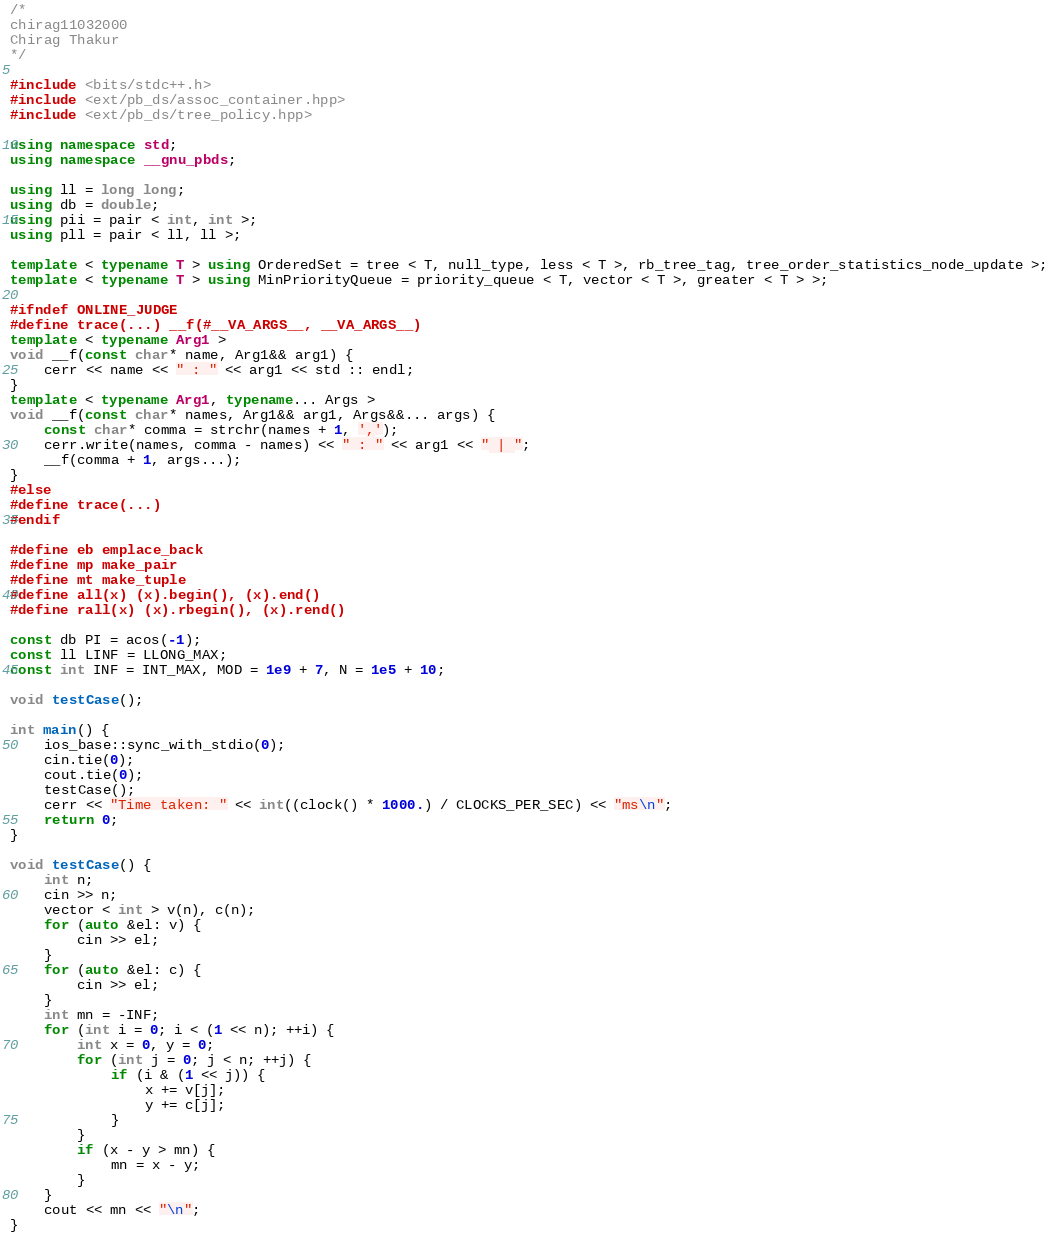Convert code to text. <code><loc_0><loc_0><loc_500><loc_500><_C++_>/* 
chirag11032000
Chirag Thakur
*/

#include <bits/stdc++.h>
#include <ext/pb_ds/assoc_container.hpp>
#include <ext/pb_ds/tree_policy.hpp>

using namespace std;
using namespace __gnu_pbds;

using ll = long long;
using db = double;
using pii = pair < int, int >;
using pll = pair < ll, ll >;

template < typename T > using OrderedSet = tree < T, null_type, less < T >, rb_tree_tag, tree_order_statistics_node_update >;
template < typename T > using MinPriorityQueue = priority_queue < T, vector < T >, greater < T > >;

#ifndef ONLINE_JUDGE
#define trace(...) __f(#__VA_ARGS__, __VA_ARGS__)
template < typename Arg1 >
void __f(const char* name, Arg1&& arg1) {
	cerr << name << " : " << arg1 << std :: endl;
}
template < typename Arg1, typename... Args >
void __f(const char* names, Arg1&& arg1, Args&&... args) {
	const char* comma = strchr(names + 1, ',');
	cerr.write(names, comma - names) << " : " << arg1 << " | ";
	__f(comma + 1, args...);
}
#else
#define trace(...)
#endif

#define eb emplace_back
#define mp make_pair
#define mt make_tuple
#define all(x) (x).begin(), (x).end()
#define rall(x) (x).rbegin(), (x).rend()

const db PI = acos(-1);
const ll LINF = LLONG_MAX;
const int INF = INT_MAX, MOD = 1e9 + 7, N = 1e5 + 10;

void testCase();

int main() {
	ios_base::sync_with_stdio(0);
	cin.tie(0);
	cout.tie(0);
	testCase();
	cerr << "Time taken: " << int((clock() * 1000.) / CLOCKS_PER_SEC) << "ms\n";
	return 0;
}

void testCase() {
	int n;
	cin >> n;
	vector < int > v(n), c(n);
	for (auto &el: v) {
		cin >> el;
	}
	for (auto &el: c) {
		cin >> el;
	}
	int mn = -INF;
	for (int i = 0; i < (1 << n); ++i) {
		int x = 0, y = 0;
		for (int j = 0; j < n; ++j) {
			if (i & (1 << j)) {
				x += v[j];
				y += c[j];
			}
		}
		if (x - y > mn) {
			mn = x - y;
		}
	}
	cout << mn << "\n";
}</code> 